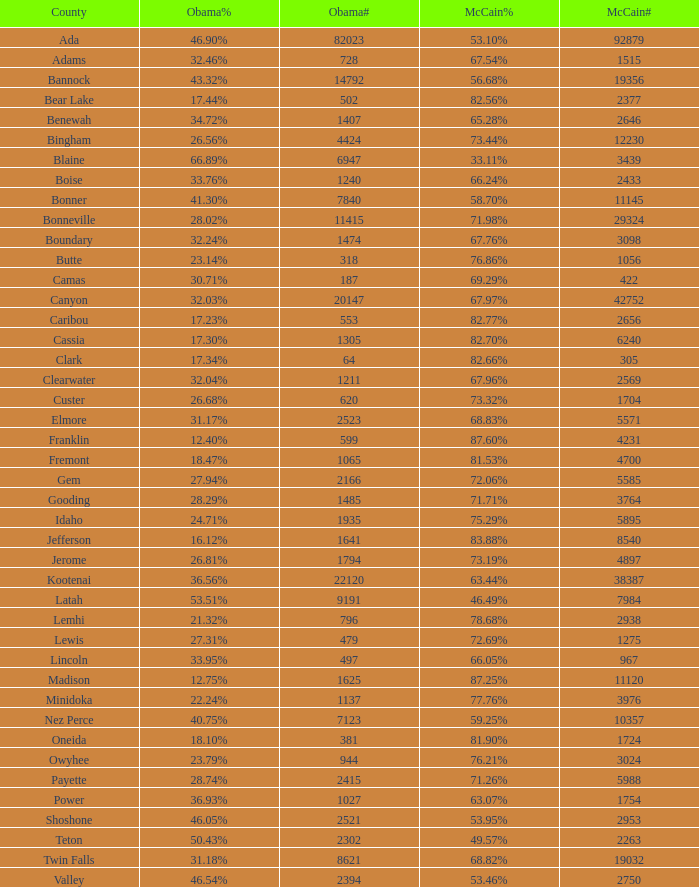What is the total number of McCain vote totals where Obama percentages was 17.34%? 1.0. 